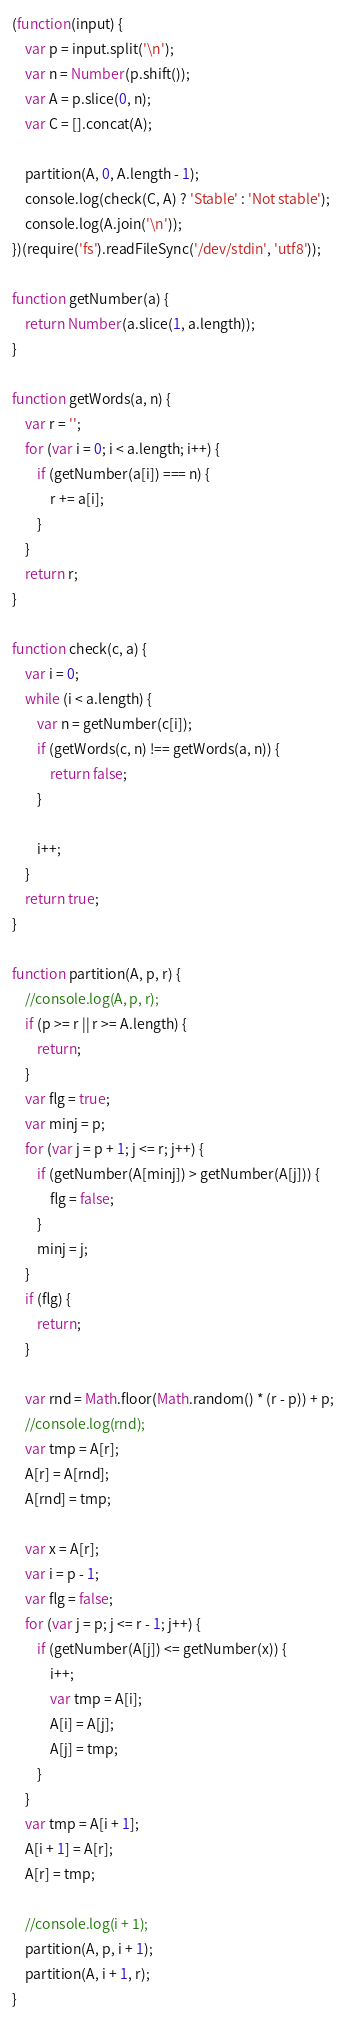Convert code to text. <code><loc_0><loc_0><loc_500><loc_500><_JavaScript_>(function(input) {
    var p = input.split('\n');
    var n = Number(p.shift());
    var A = p.slice(0, n);
    var C = [].concat(A);

    partition(A, 0, A.length - 1);
    console.log(check(C, A) ? 'Stable' : 'Not stable');
    console.log(A.join('\n'));
})(require('fs').readFileSync('/dev/stdin', 'utf8'));

function getNumber(a) {
    return Number(a.slice(1, a.length));
}

function getWords(a, n) {
    var r = '';
    for (var i = 0; i < a.length; i++) {
        if (getNumber(a[i]) === n) {
            r += a[i];
        }
    }
    return r;
}

function check(c, a) {
    var i = 0;
    while (i < a.length) {
        var n = getNumber(c[i]);
        if (getWords(c, n) !== getWords(a, n)) {
            return false;
        }

        i++;
    }
    return true;
}

function partition(A, p, r) {
    //console.log(A, p, r);
    if (p >= r || r >= A.length) {
        return;
    }
    var flg = true;
    var minj = p;
    for (var j = p + 1; j <= r; j++) {
        if (getNumber(A[minj]) > getNumber(A[j])) {
            flg = false;
        }
        minj = j;
    }
    if (flg) {
        return;
    }

    var rnd = Math.floor(Math.random() * (r - p)) + p;
    //console.log(rnd);
    var tmp = A[r];
    A[r] = A[rnd];
    A[rnd] = tmp;

    var x = A[r];
    var i = p - 1;
    var flg = false;
    for (var j = p; j <= r - 1; j++) {
        if (getNumber(A[j]) <= getNumber(x)) {
            i++;
            var tmp = A[i];
            A[i] = A[j];
            A[j] = tmp;
        }
    }
    var tmp = A[i + 1];
    A[i + 1] = A[r];
    A[r] = tmp;

    //console.log(i + 1);
    partition(A, p, i + 1);
    partition(A, i + 1, r);
}</code> 